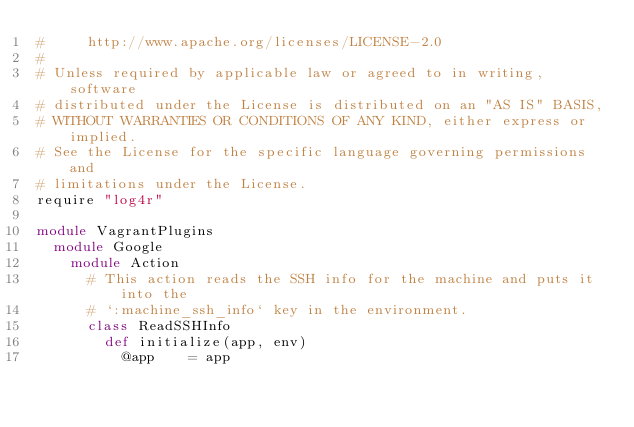Convert code to text. <code><loc_0><loc_0><loc_500><loc_500><_Ruby_>#     http://www.apache.org/licenses/LICENSE-2.0
#
# Unless required by applicable law or agreed to in writing, software
# distributed under the License is distributed on an "AS IS" BASIS,
# WITHOUT WARRANTIES OR CONDITIONS OF ANY KIND, either express or implied.
# See the License for the specific language governing permissions and
# limitations under the License.
require "log4r"

module VagrantPlugins
  module Google
    module Action
      # This action reads the SSH info for the machine and puts it into the
      # `:machine_ssh_info` key in the environment.
      class ReadSSHInfo
        def initialize(app, env)
          @app    = app</code> 